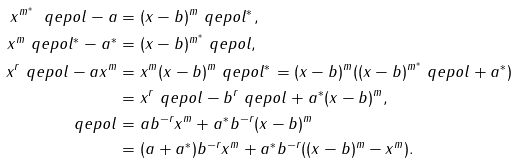<formula> <loc_0><loc_0><loc_500><loc_500>x ^ { m ^ { * } } \ q e p o l - a & = ( x - b ) ^ { m } \ q e p o l ^ { * } , \\ x ^ { m } \ q e p o l ^ { * } - a ^ { * } & = ( x - b ) ^ { m ^ { * } } \ q e p o l , \\ x ^ { r } \ q e p o l - a x ^ { m } & = x ^ { m } ( x - b ) ^ { m } \ q e p o l ^ { * } = ( x - b ) ^ { m } ( ( x - b ) ^ { m ^ { * } } \ q e p o l + a ^ { * } ) \\ & = x ^ { r } \ q e p o l - b ^ { r } \ q e p o l + a ^ { * } ( x - b ) ^ { m } , \\ \ q e p o l & = a b ^ { - r } x ^ { m } + a ^ { * } b ^ { - r } ( x - b ) ^ { m } \\ & = ( a + a ^ { * } ) b ^ { - r } x ^ { m } + a ^ { * } b ^ { - r } ( ( x - b ) ^ { m } - x ^ { m } ) .</formula> 